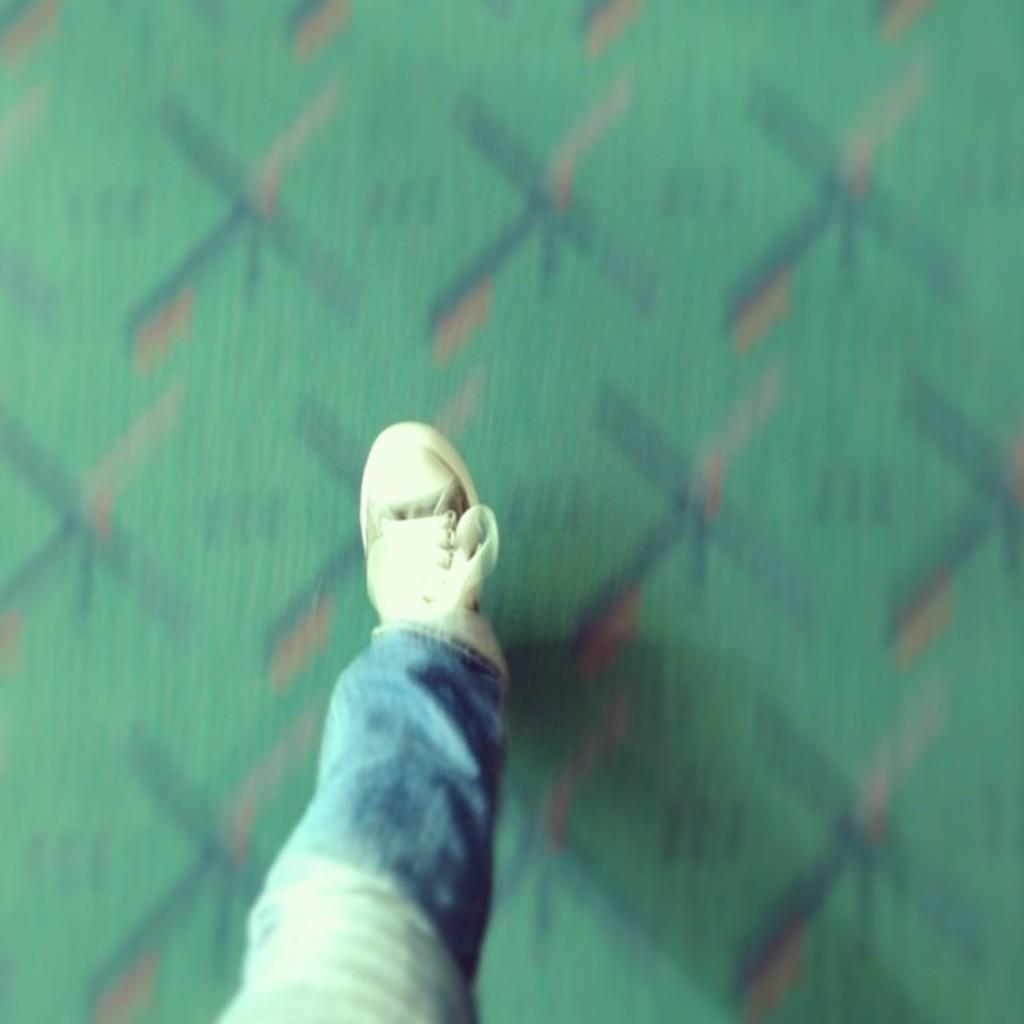In one or two sentences, can you explain what this image depicts? In this image we can see a person's leg. In the background of the image there is a blur background. 